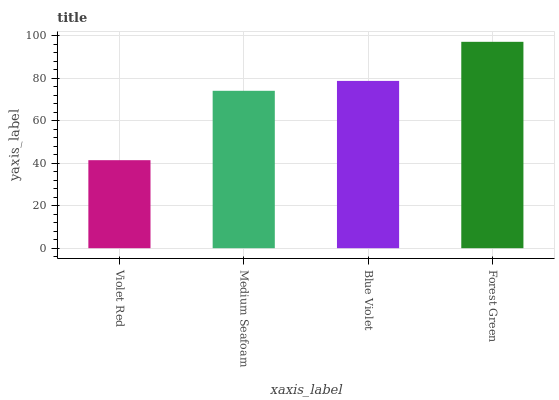Is Violet Red the minimum?
Answer yes or no. Yes. Is Forest Green the maximum?
Answer yes or no. Yes. Is Medium Seafoam the minimum?
Answer yes or no. No. Is Medium Seafoam the maximum?
Answer yes or no. No. Is Medium Seafoam greater than Violet Red?
Answer yes or no. Yes. Is Violet Red less than Medium Seafoam?
Answer yes or no. Yes. Is Violet Red greater than Medium Seafoam?
Answer yes or no. No. Is Medium Seafoam less than Violet Red?
Answer yes or no. No. Is Blue Violet the high median?
Answer yes or no. Yes. Is Medium Seafoam the low median?
Answer yes or no. Yes. Is Forest Green the high median?
Answer yes or no. No. Is Forest Green the low median?
Answer yes or no. No. 